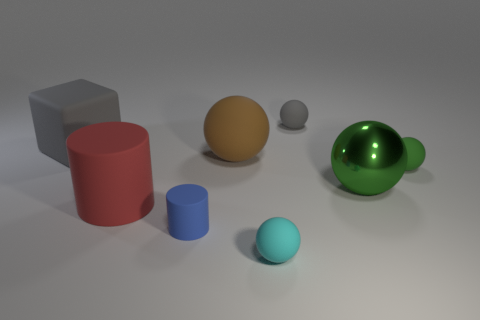Are there any matte objects that have the same color as the large block?
Offer a very short reply. Yes. What is the color of the shiny ball that is the same size as the gray matte cube?
Ensure brevity in your answer.  Green. Do the tiny matte object behind the cube and the large matte cube have the same color?
Your response must be concise. Yes. Are there any red cylinders that have the same material as the small gray ball?
Ensure brevity in your answer.  Yes. There is a small object that is the same color as the block; what is its shape?
Ensure brevity in your answer.  Sphere. Is the number of small blue matte cylinders that are to the right of the tiny cyan rubber ball less than the number of cylinders?
Your response must be concise. Yes. There is a gray object right of the cyan thing; does it have the same size as the tiny cyan thing?
Offer a terse response. Yes. What number of other tiny things are the same shape as the tiny gray matte object?
Provide a succinct answer. 2. There is a red thing that is made of the same material as the brown thing; what is its size?
Offer a terse response. Large. Is the number of big red cylinders that are on the right side of the small blue thing the same as the number of blue things?
Offer a very short reply. No. 